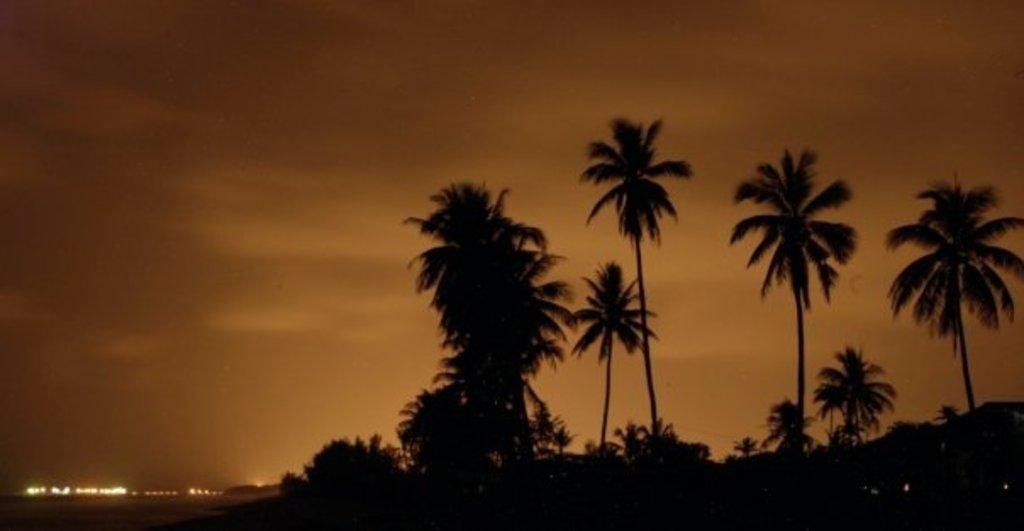What type of natural elements can be seen in the image? There are trees in the image. What artificial elements can be seen in the image? There are lights in the image. What is visible in the background of the image? The sky is visible in the background of the image. How many times did the driver adjust the rearview mirror in the image? There is no driver or rearview mirror present in the image, so it is not possible to answer that question. 